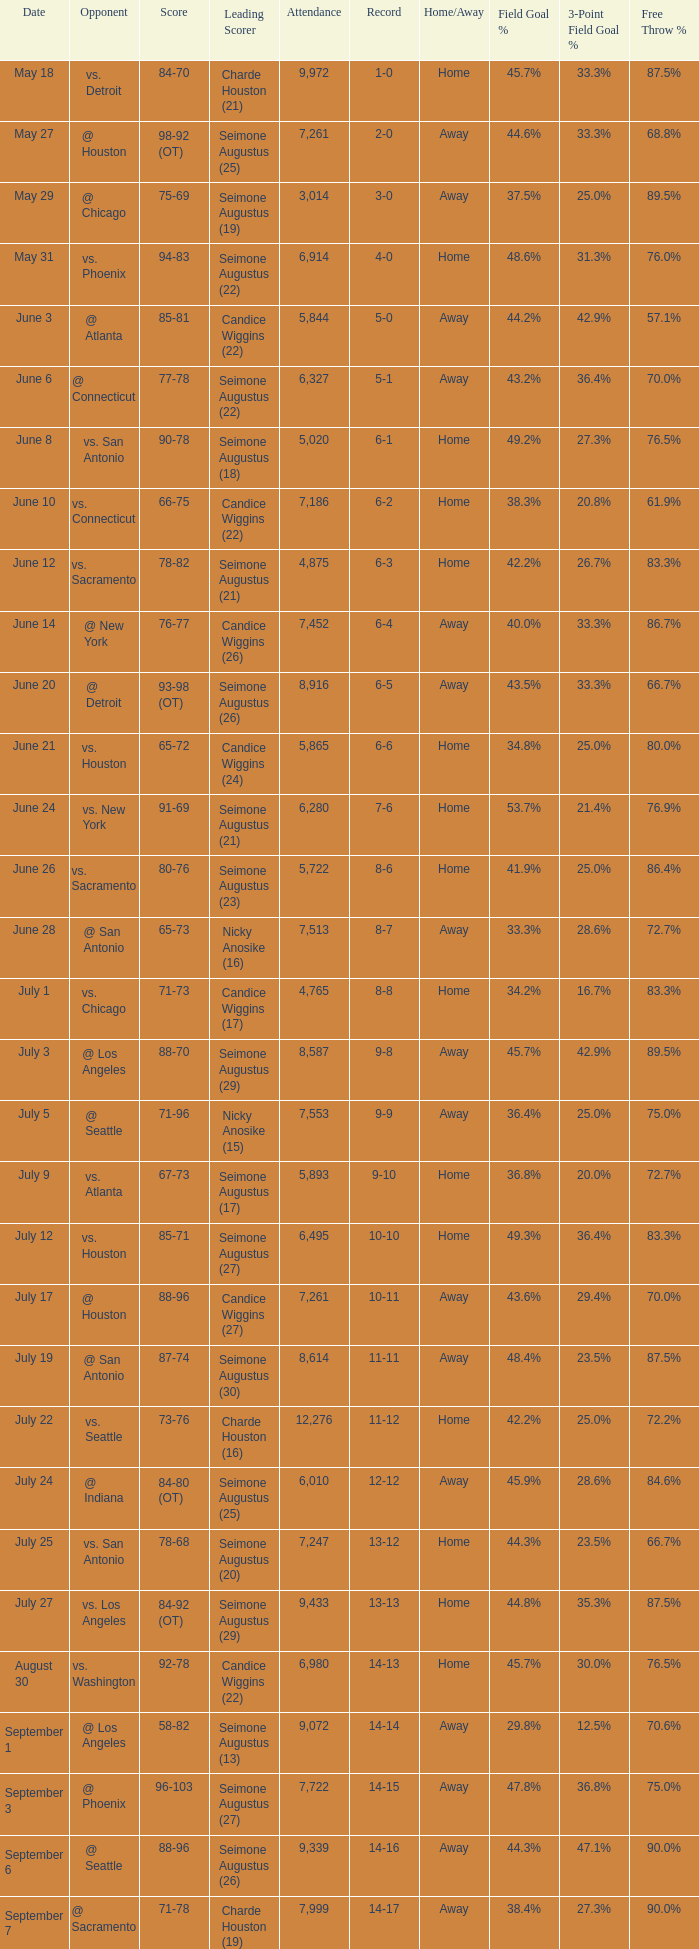Which Leading Scorer has an Opponent of @ seattle, and a Record of 14-16? Seimone Augustus (26). 